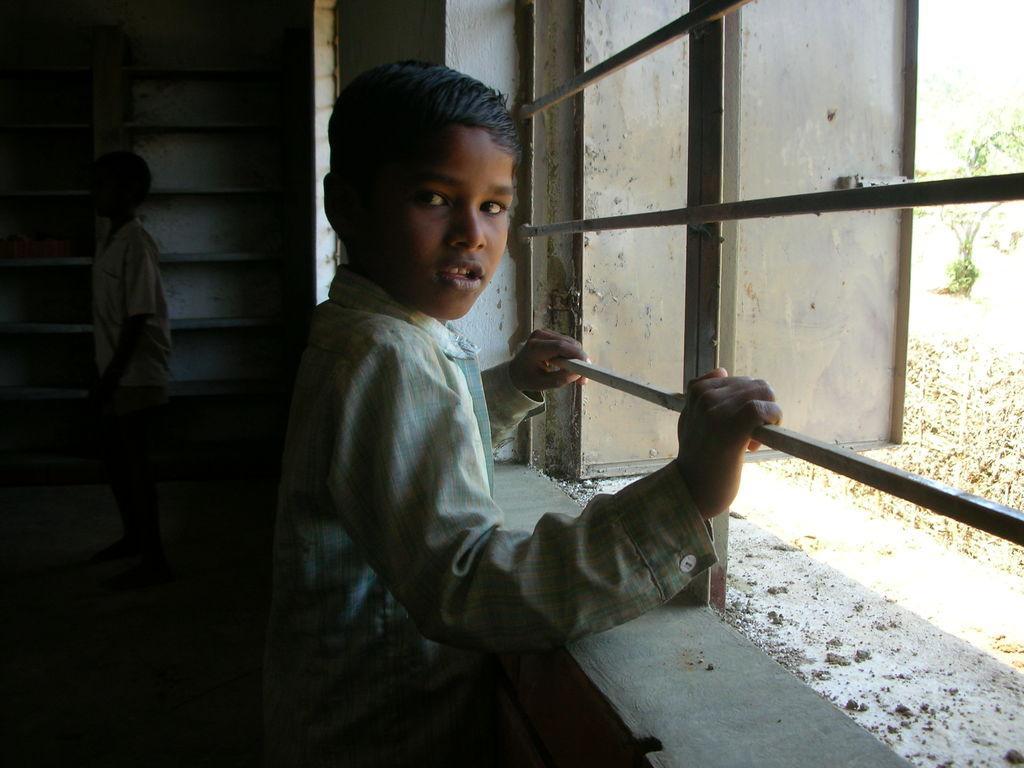Can you describe this image briefly? In this image there are persons standing. On the right side there is a window and in the background there is an object which is white in colour. Behind the window on the right side there is a tree which is visible. 